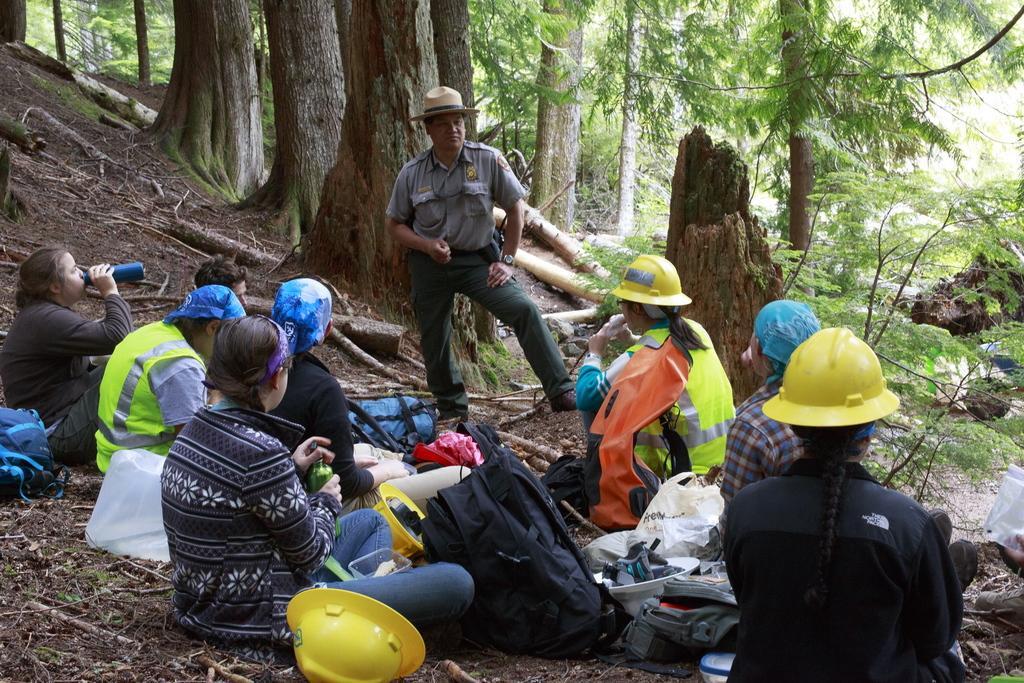Please provide a concise description of this image. In this image in the center there are persons sitting and there is a man standing in the center wearing brown colour hat. On the ground there are bags, there are helmets, and there are dry leaves, there is grass. In the background there are trees. 